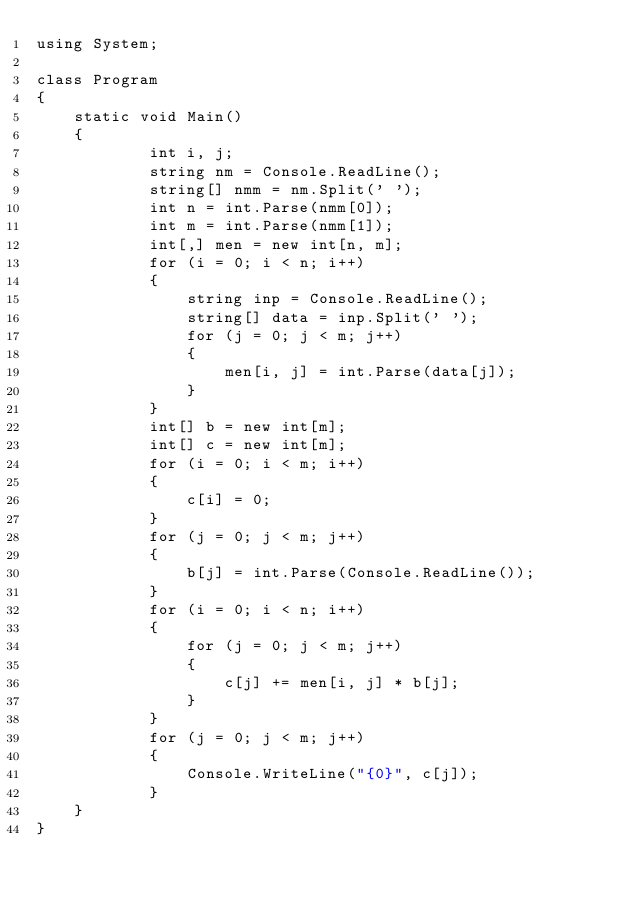Convert code to text. <code><loc_0><loc_0><loc_500><loc_500><_C#_>using System;

class Program
{
    static void Main()
    {
            int i, j;
            string nm = Console.ReadLine();
            string[] nmm = nm.Split(' ');
            int n = int.Parse(nmm[0]);
            int m = int.Parse(nmm[1]);
            int[,] men = new int[n, m];
            for (i = 0; i < n; i++)
            {
                string inp = Console.ReadLine();
                string[] data = inp.Split(' ');
                for (j = 0; j < m; j++)
                {
                    men[i, j] = int.Parse(data[j]);
                }
            }
            int[] b = new int[m];
            int[] c = new int[m];
            for (i = 0; i < m; i++)
            {
                c[i] = 0;
            }
            for (j = 0; j < m; j++)
            {
                b[j] = int.Parse(Console.ReadLine());
            }
            for (i = 0; i < n; i++)
            {
                for (j = 0; j < m; j++)
                {
                    c[j] += men[i, j] * b[j];
                }
            }
            for (j = 0; j < m; j++)
            {
                Console.WriteLine("{0}", c[j]);
            }
    }
}
</code> 